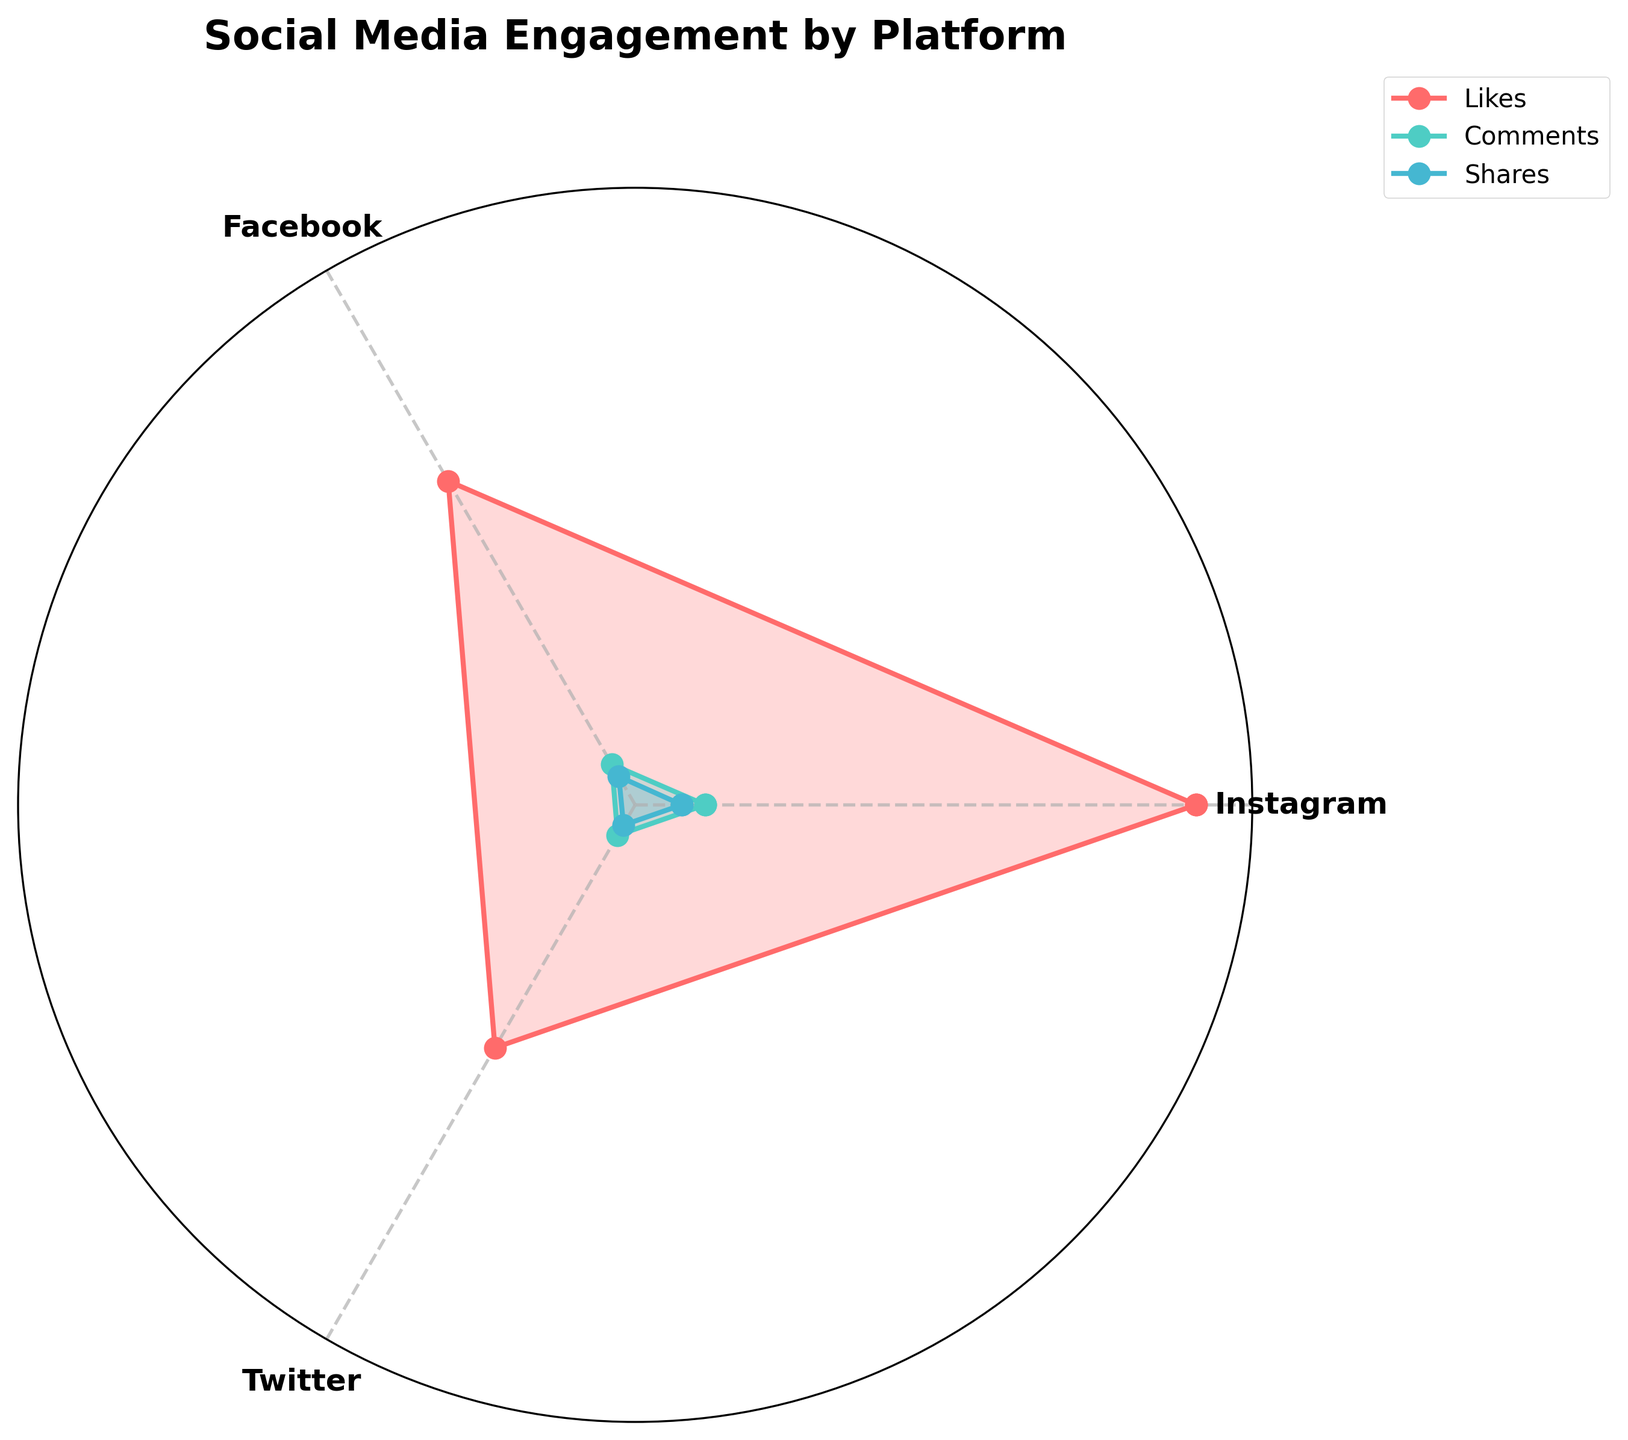What is the title of the chart? The title is displayed at the top of the chart, stating the main topic it represents.
Answer: Social Media Engagement by Platform Which platform has the highest number of likes? The highest value point of the 'Likes' line (color #FF6B6B) on the chart is at the angle representing Instagram.
Answer: Instagram Which engagement metric has the lowest value across all platforms? Look at the smallest value on the plot. The minimum values of each line show that 'Shares' (color #45B7D1) have the lowest value across all platforms.
Answer: Shares What is the sum of likes, comments, and shares for Facebook? Identify the values for Facebook and sum them up: 800 (likes) + 100 (comments) + 70 (shares) = 970.
Answer: 970 Which platforms have higher comments compared to shares? Compare the 'Comments' line (color #4ECDC4) and 'Shares' line (color #45B7D1) at each platform’s angle. Both Instagram and Facebook have higher comments compared to shares.
Answer: Instagram, Facebook What is the average number of engagements (likes, comments, shares) on Twitter? Gather the values for Twitter: 600 (likes), 75 (comments), 50 (shares). Calculate the average: (600 + 75 + 50) / 3 = 241.67.
Answer: 241.67 How do Instagram shares compare to Twitter shares? Compare the points on the 'Shares' line at the respective angles for Instagram and Twitter. Instagram shares are 100, and Twitter shares are 50.
Answer: Instagram has more shares than Twitter What color represents comments on the chart? Observe the legend to find the line color for 'Comments'.
Answer: Teal (color #4ECDC4) Which platform shows the most significant difference between likes and comments? Calculate the difference for each platform by subtracting comments from likes. The largest difference is for Instagram: 1200 - 150 = 1050.
Answer: Instagram 